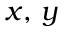Convert formula to latex. <formula><loc_0><loc_0><loc_500><loc_500>x , \, y</formula> 